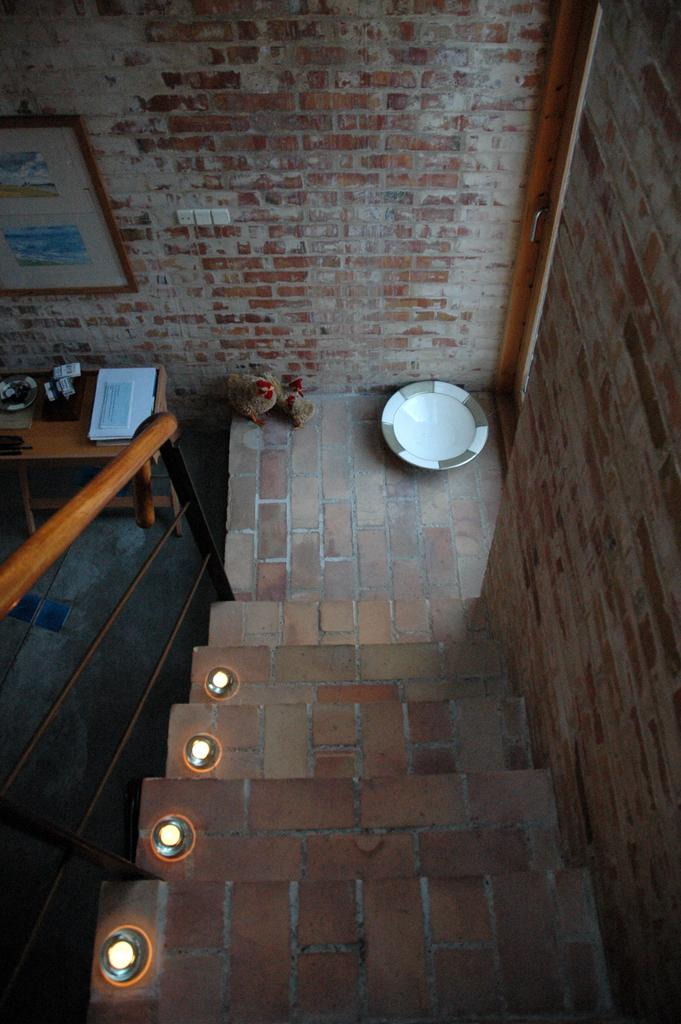What is located in the middle of the image? There are lights in the middle of the image. What architectural feature can be seen in the image? There is a staircase in the image. What object might be used for serving food in the image? There is a plate in the image. What piece of furniture is present in the image? There is a table in the image. What type of items can be seen on the table? There are papers in the image. What type of items can be seen on the floor? There are toys in the image. What type of decorative item is present in the image? There is a photo frame in the image. What type of entrance can be seen in the image? There is a door in the image. What type of structure is visible in the image? A: There is a wall in the image. What type of grass can be seen growing on the wall in the image? There is no grass present on the wall in the image. What type of pin can be seen holding the papers together in the image? There is no pin visible in the image; the papers are not held together. 